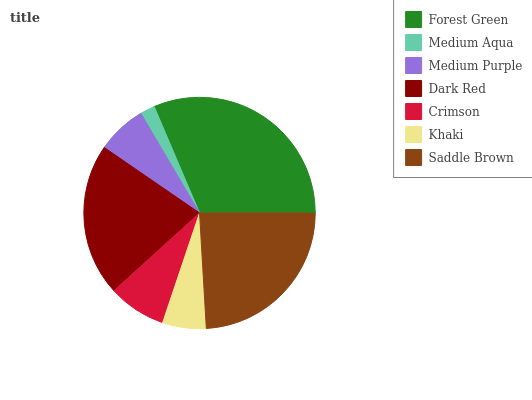Is Medium Aqua the minimum?
Answer yes or no. Yes. Is Forest Green the maximum?
Answer yes or no. Yes. Is Medium Purple the minimum?
Answer yes or no. No. Is Medium Purple the maximum?
Answer yes or no. No. Is Medium Purple greater than Medium Aqua?
Answer yes or no. Yes. Is Medium Aqua less than Medium Purple?
Answer yes or no. Yes. Is Medium Aqua greater than Medium Purple?
Answer yes or no. No. Is Medium Purple less than Medium Aqua?
Answer yes or no. No. Is Crimson the high median?
Answer yes or no. Yes. Is Crimson the low median?
Answer yes or no. Yes. Is Dark Red the high median?
Answer yes or no. No. Is Khaki the low median?
Answer yes or no. No. 